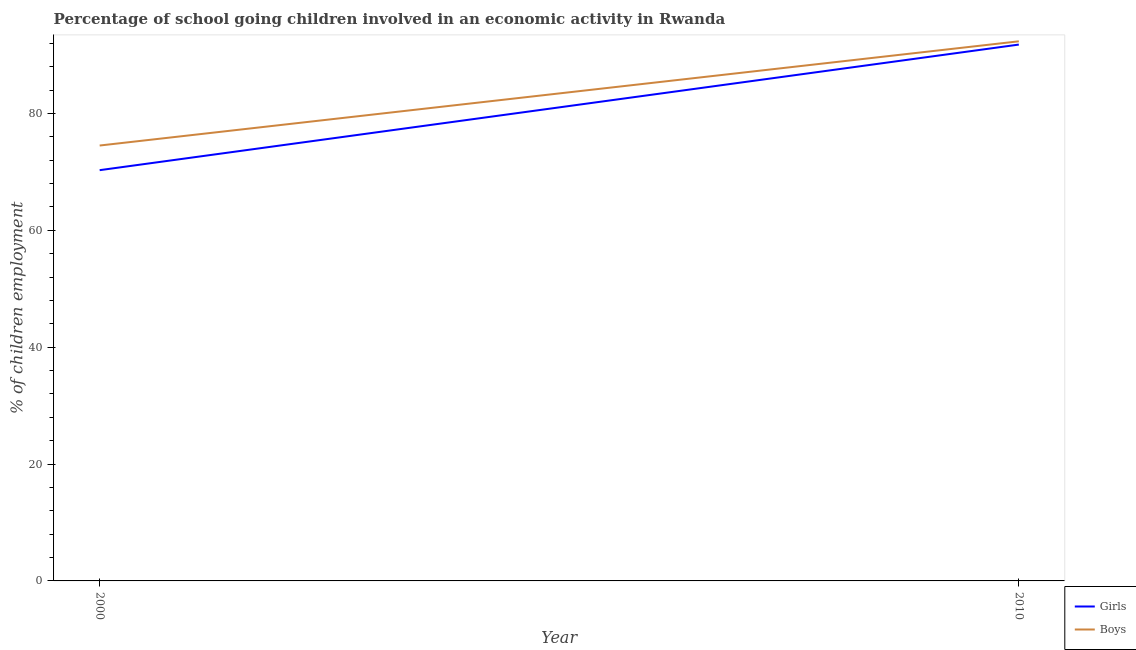How many different coloured lines are there?
Provide a short and direct response. 2. Does the line corresponding to percentage of school going boys intersect with the line corresponding to percentage of school going girls?
Give a very brief answer. No. What is the percentage of school going boys in 2010?
Ensure brevity in your answer.  92.35. Across all years, what is the maximum percentage of school going girls?
Offer a terse response. 91.79. Across all years, what is the minimum percentage of school going boys?
Provide a short and direct response. 74.52. What is the total percentage of school going boys in the graph?
Give a very brief answer. 166.87. What is the difference between the percentage of school going boys in 2000 and that in 2010?
Make the answer very short. -17.83. What is the difference between the percentage of school going girls in 2010 and the percentage of school going boys in 2000?
Your response must be concise. 17.28. What is the average percentage of school going boys per year?
Offer a very short reply. 83.43. In the year 2010, what is the difference between the percentage of school going boys and percentage of school going girls?
Give a very brief answer. 0.56. What is the ratio of the percentage of school going boys in 2000 to that in 2010?
Give a very brief answer. 0.81. Is the percentage of school going boys in 2000 less than that in 2010?
Keep it short and to the point. Yes. In how many years, is the percentage of school going boys greater than the average percentage of school going boys taken over all years?
Your response must be concise. 1. Does the percentage of school going girls monotonically increase over the years?
Ensure brevity in your answer.  Yes. Is the percentage of school going girls strictly greater than the percentage of school going boys over the years?
Provide a succinct answer. No. Is the percentage of school going girls strictly less than the percentage of school going boys over the years?
Your answer should be very brief. Yes. How many lines are there?
Ensure brevity in your answer.  2. What is the difference between two consecutive major ticks on the Y-axis?
Your answer should be compact. 20. Are the values on the major ticks of Y-axis written in scientific E-notation?
Your response must be concise. No. Does the graph contain grids?
Provide a short and direct response. No. Where does the legend appear in the graph?
Offer a terse response. Bottom right. What is the title of the graph?
Keep it short and to the point. Percentage of school going children involved in an economic activity in Rwanda. Does "Non-resident workers" appear as one of the legend labels in the graph?
Provide a short and direct response. No. What is the label or title of the Y-axis?
Provide a short and direct response. % of children employment. What is the % of children employment in Girls in 2000?
Provide a short and direct response. 70.3. What is the % of children employment in Boys in 2000?
Offer a very short reply. 74.52. What is the % of children employment in Girls in 2010?
Keep it short and to the point. 91.79. What is the % of children employment in Boys in 2010?
Give a very brief answer. 92.35. Across all years, what is the maximum % of children employment in Girls?
Your answer should be compact. 91.79. Across all years, what is the maximum % of children employment in Boys?
Your answer should be very brief. 92.35. Across all years, what is the minimum % of children employment in Girls?
Give a very brief answer. 70.3. Across all years, what is the minimum % of children employment of Boys?
Offer a very short reply. 74.52. What is the total % of children employment of Girls in the graph?
Keep it short and to the point. 162.09. What is the total % of children employment of Boys in the graph?
Provide a short and direct response. 166.87. What is the difference between the % of children employment of Girls in 2000 and that in 2010?
Provide a short and direct response. -21.49. What is the difference between the % of children employment in Boys in 2000 and that in 2010?
Give a very brief answer. -17.83. What is the difference between the % of children employment in Girls in 2000 and the % of children employment in Boys in 2010?
Provide a short and direct response. -22.05. What is the average % of children employment in Girls per year?
Ensure brevity in your answer.  81.04. What is the average % of children employment of Boys per year?
Your answer should be compact. 83.43. In the year 2000, what is the difference between the % of children employment of Girls and % of children employment of Boys?
Offer a very short reply. -4.22. In the year 2010, what is the difference between the % of children employment of Girls and % of children employment of Boys?
Provide a succinct answer. -0.56. What is the ratio of the % of children employment of Girls in 2000 to that in 2010?
Ensure brevity in your answer.  0.77. What is the ratio of the % of children employment in Boys in 2000 to that in 2010?
Offer a very short reply. 0.81. What is the difference between the highest and the second highest % of children employment of Girls?
Provide a succinct answer. 21.49. What is the difference between the highest and the second highest % of children employment of Boys?
Offer a very short reply. 17.83. What is the difference between the highest and the lowest % of children employment in Girls?
Keep it short and to the point. 21.49. What is the difference between the highest and the lowest % of children employment in Boys?
Make the answer very short. 17.83. 